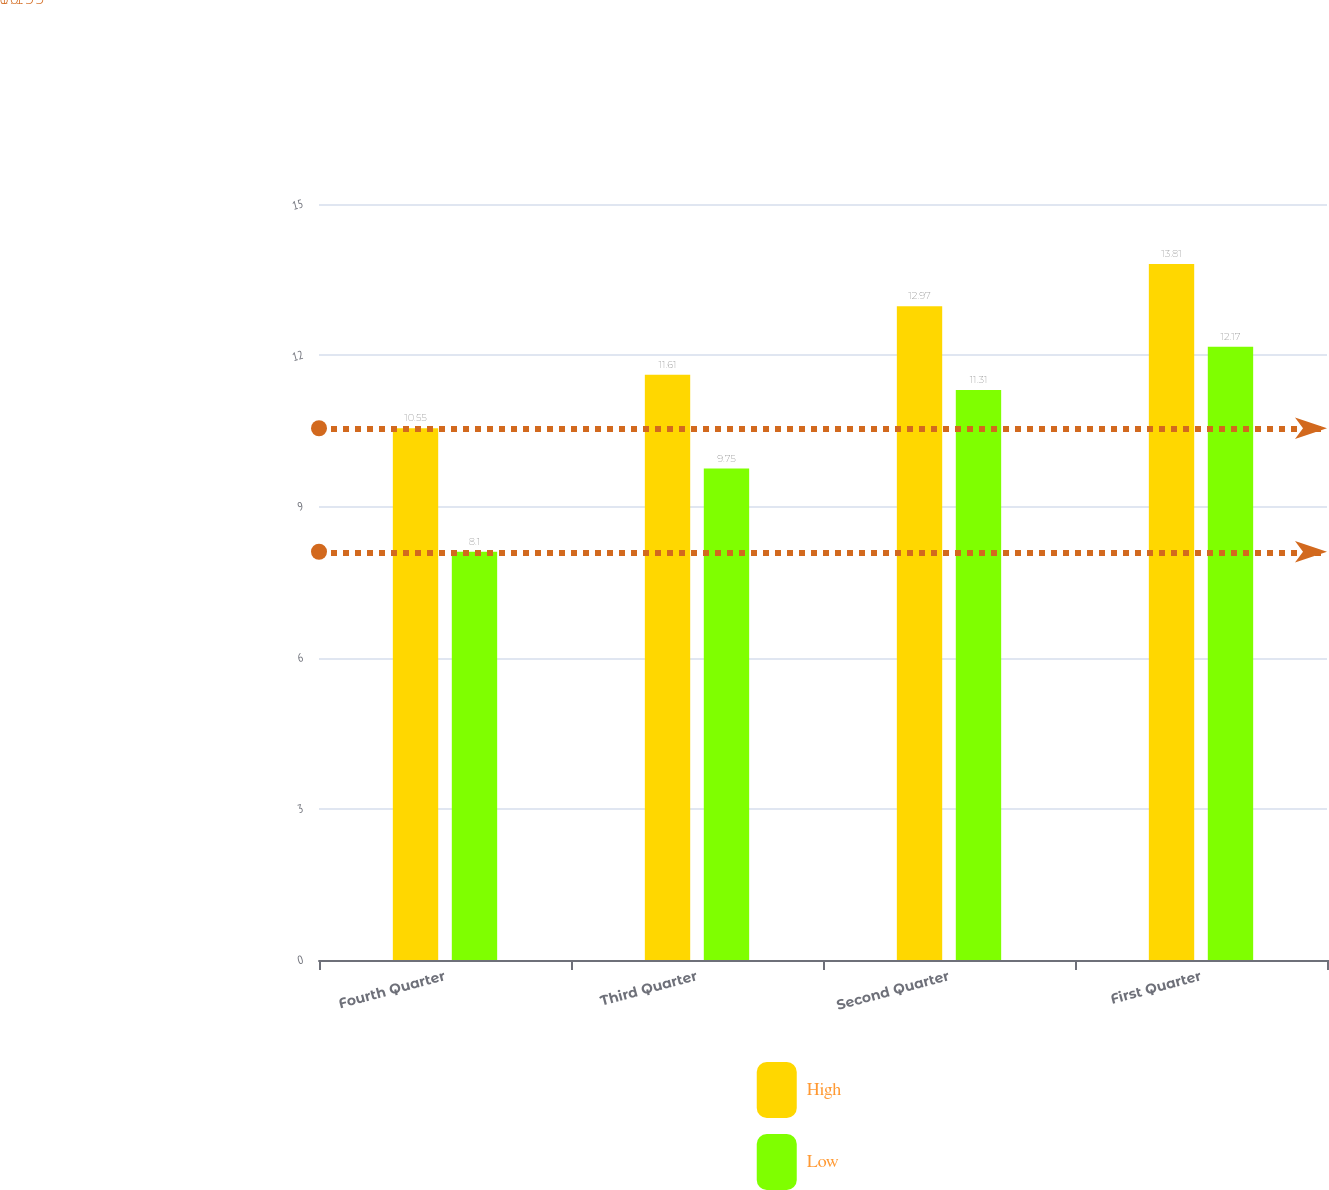Convert chart. <chart><loc_0><loc_0><loc_500><loc_500><stacked_bar_chart><ecel><fcel>Fourth Quarter<fcel>Third Quarter<fcel>Second Quarter<fcel>First Quarter<nl><fcel>High<fcel>10.55<fcel>11.61<fcel>12.97<fcel>13.81<nl><fcel>Low<fcel>8.1<fcel>9.75<fcel>11.31<fcel>12.17<nl></chart> 